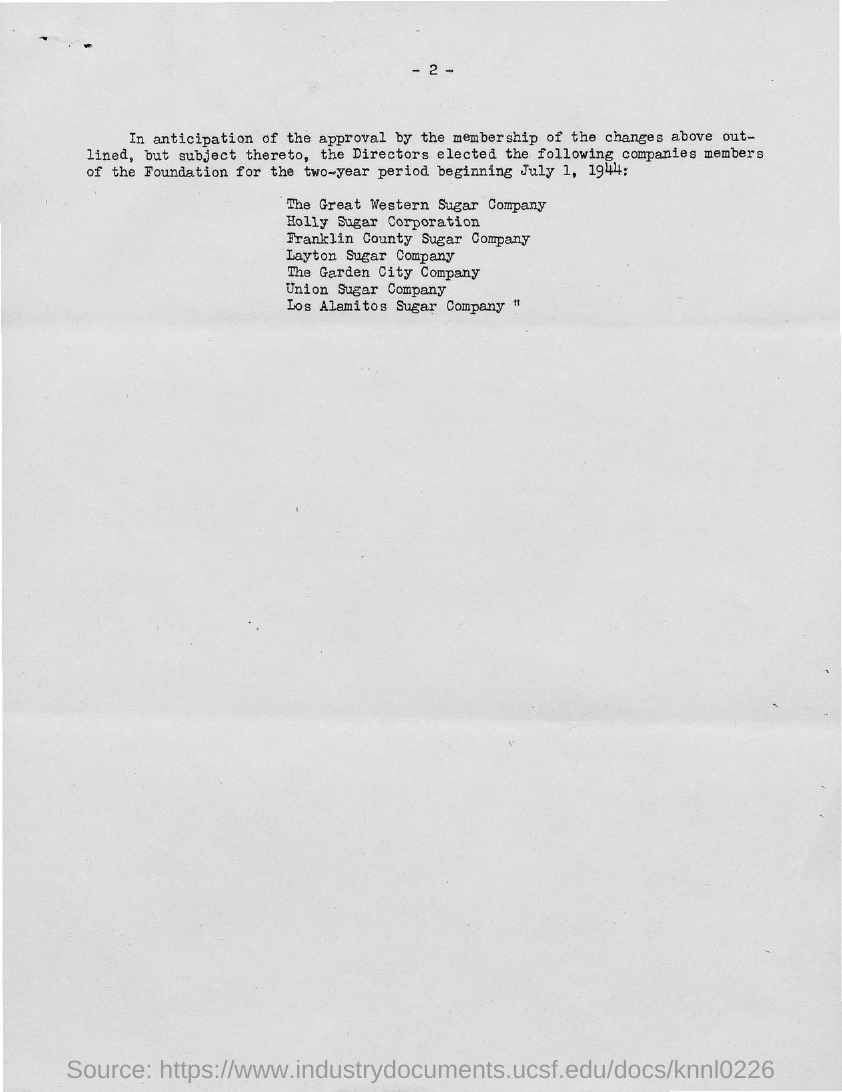Identify some key points in this picture. The page number mentioned in this document is 2. 